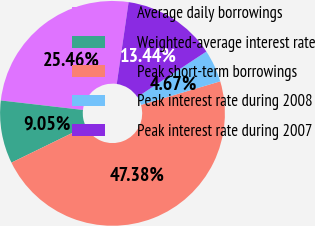<chart> <loc_0><loc_0><loc_500><loc_500><pie_chart><fcel>Average daily borrowings<fcel>Weighted-average interest rate<fcel>Peak short-term borrowings<fcel>Peak interest rate during 2008<fcel>Peak interest rate during 2007<nl><fcel>25.46%<fcel>9.05%<fcel>47.38%<fcel>4.67%<fcel>13.44%<nl></chart> 